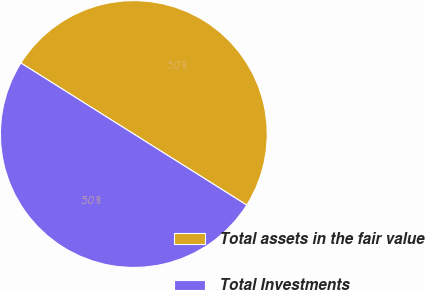Convert chart to OTSL. <chart><loc_0><loc_0><loc_500><loc_500><pie_chart><fcel>Total assets in the fair value<fcel>Total Investments<nl><fcel>50.0%<fcel>50.0%<nl></chart> 